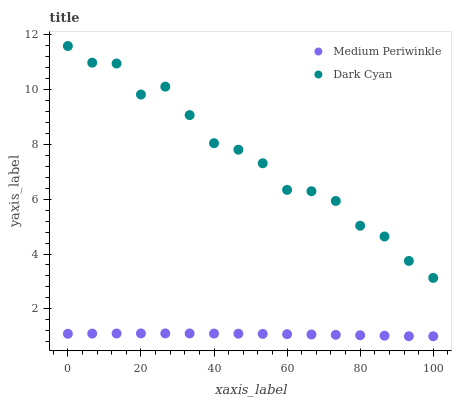Does Medium Periwinkle have the minimum area under the curve?
Answer yes or no. Yes. Does Dark Cyan have the maximum area under the curve?
Answer yes or no. Yes. Does Medium Periwinkle have the maximum area under the curve?
Answer yes or no. No. Is Medium Periwinkle the smoothest?
Answer yes or no. Yes. Is Dark Cyan the roughest?
Answer yes or no. Yes. Is Medium Periwinkle the roughest?
Answer yes or no. No. Does Medium Periwinkle have the lowest value?
Answer yes or no. Yes. Does Dark Cyan have the highest value?
Answer yes or no. Yes. Does Medium Periwinkle have the highest value?
Answer yes or no. No. Is Medium Periwinkle less than Dark Cyan?
Answer yes or no. Yes. Is Dark Cyan greater than Medium Periwinkle?
Answer yes or no. Yes. Does Medium Periwinkle intersect Dark Cyan?
Answer yes or no. No. 